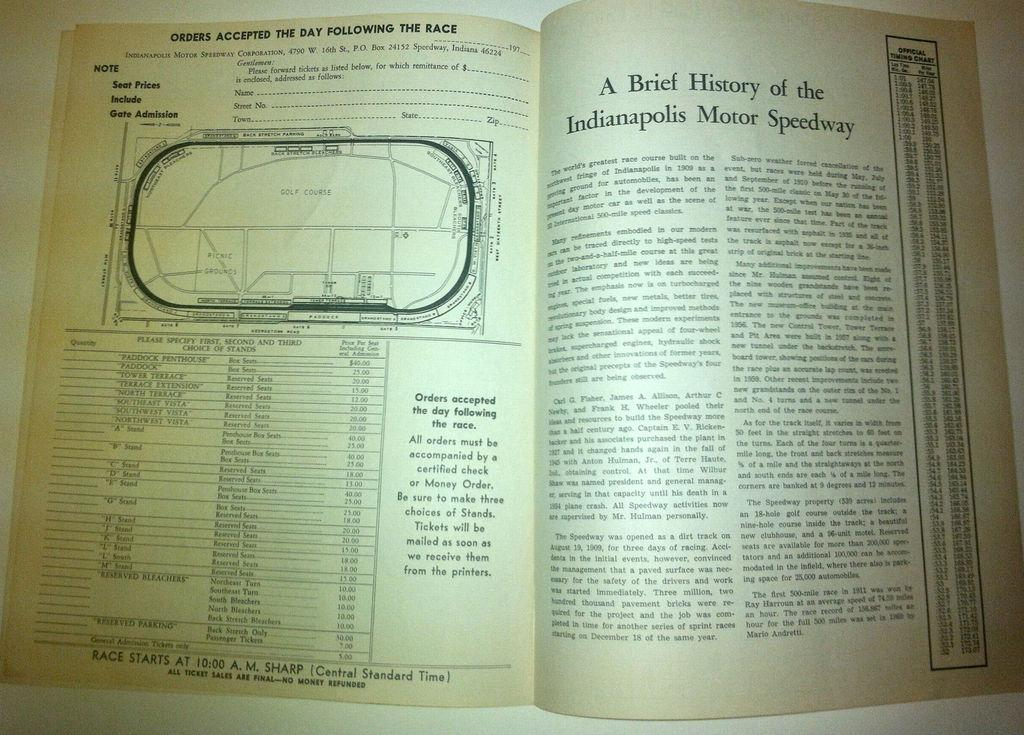Provide a one-sentence caption for the provided image. A book opened with the page on the right talking about the history of the Indianapolis Motor Speedway. 